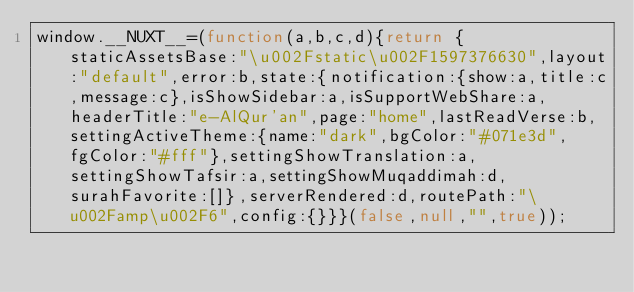Convert code to text. <code><loc_0><loc_0><loc_500><loc_500><_JavaScript_>window.__NUXT__=(function(a,b,c,d){return {staticAssetsBase:"\u002Fstatic\u002F1597376630",layout:"default",error:b,state:{notification:{show:a,title:c,message:c},isShowSidebar:a,isSupportWebShare:a,headerTitle:"e-AlQur'an",page:"home",lastReadVerse:b,settingActiveTheme:{name:"dark",bgColor:"#071e3d",fgColor:"#fff"},settingShowTranslation:a,settingShowTafsir:a,settingShowMuqaddimah:d,surahFavorite:[]},serverRendered:d,routePath:"\u002Famp\u002F6",config:{}}}(false,null,"",true));</code> 